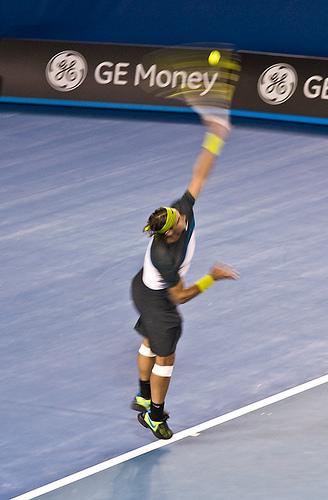What is on the player's knees?
Give a very brief answer. Knee pads. What company is sponsoring this game?
Keep it brief. Ge money. Is this a professional player?
Concise answer only. Yes. 